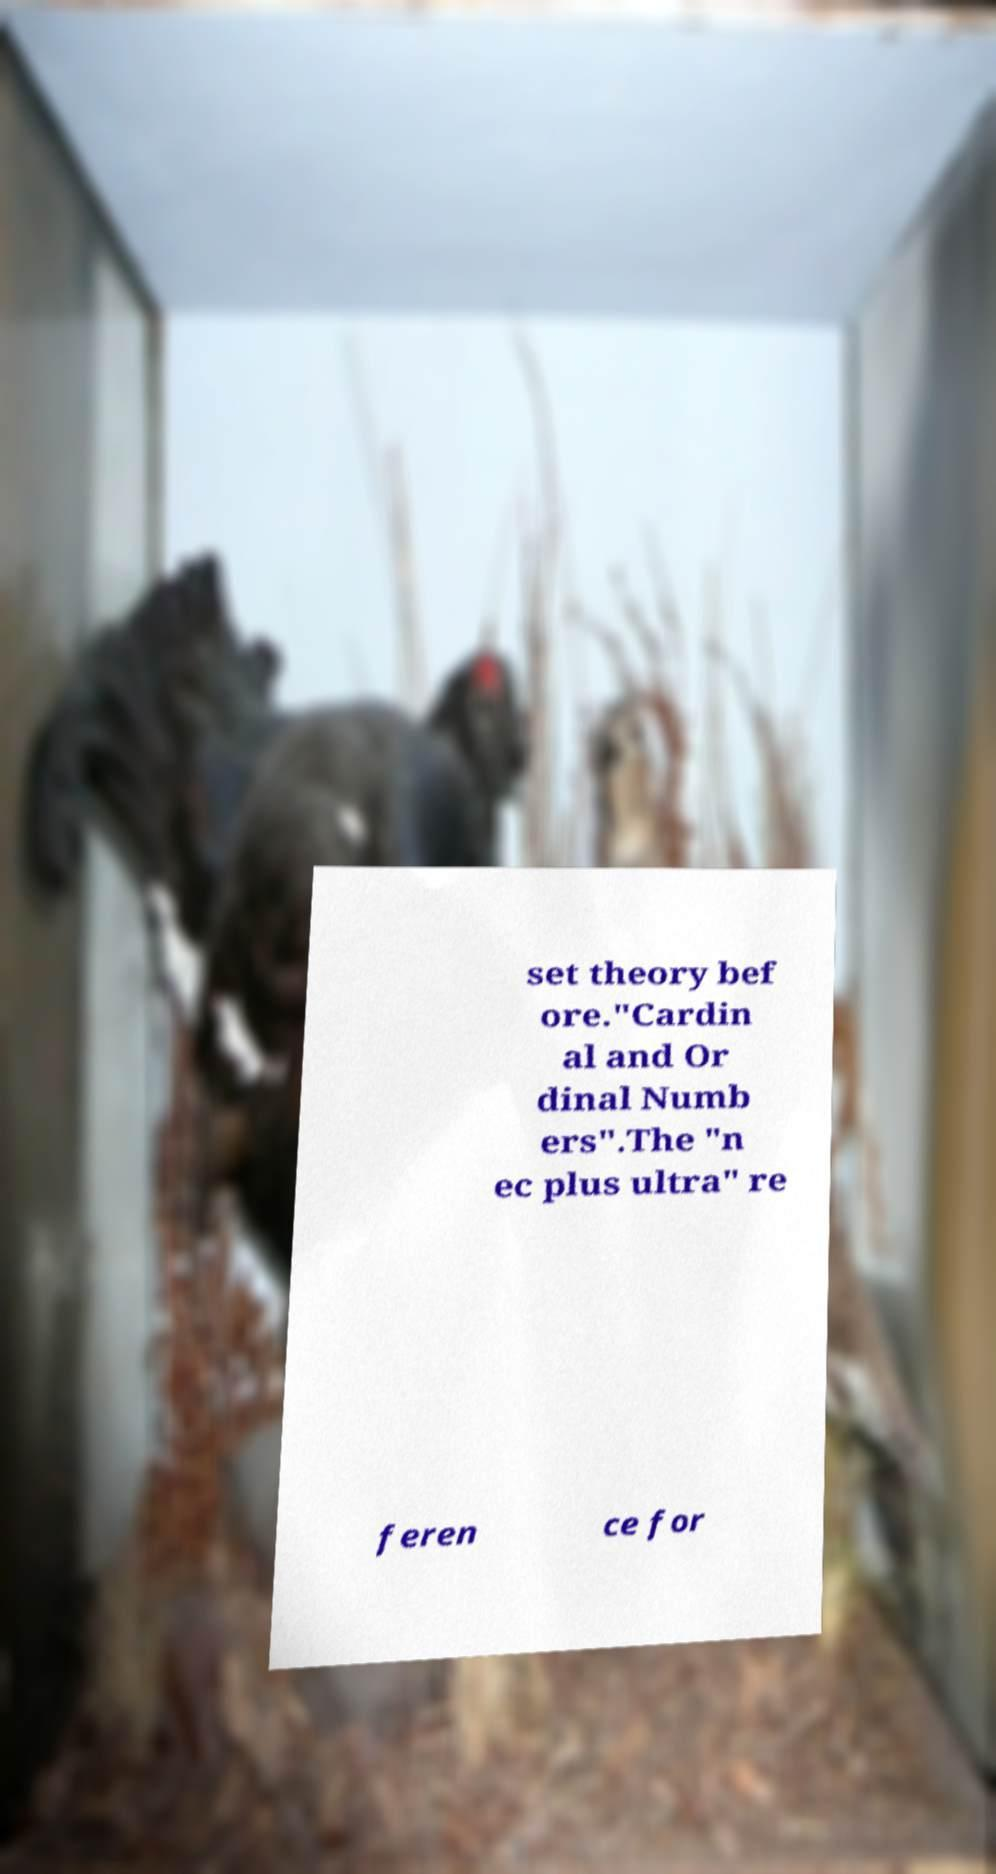Can you accurately transcribe the text from the provided image for me? set theory bef ore."Cardin al and Or dinal Numb ers".The "n ec plus ultra" re feren ce for 